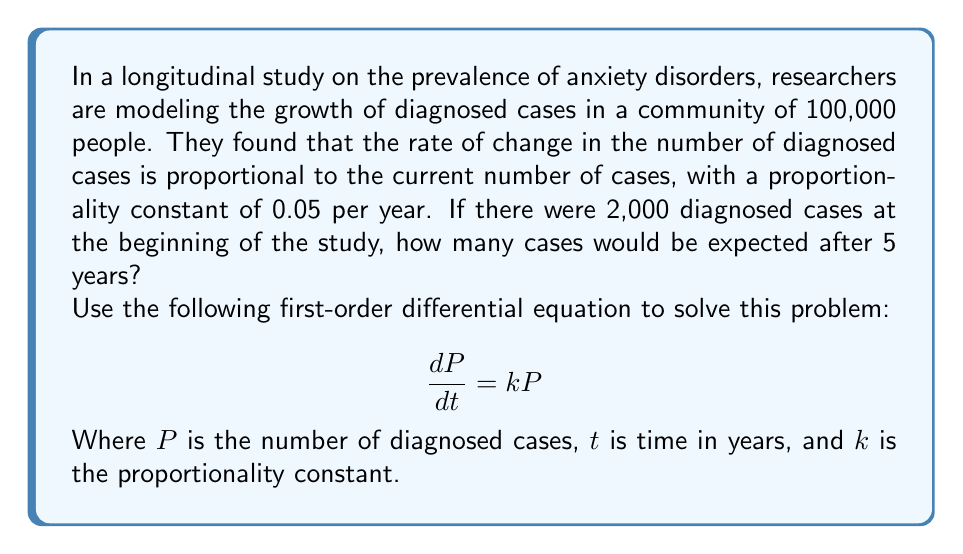Teach me how to tackle this problem. To solve this problem, we'll use the given first-order differential equation and the initial conditions:

1. Given differential equation: $\frac{dP}{dt} = kP$
2. Initial condition: $P(0) = 2000$
3. Proportionality constant: $k = 0.05$
4. Time period: $t = 5$ years

Step 1: Solve the differential equation
The solution to this equation is an exponential function:
$$P(t) = P_0e^{kt}$$
Where $P_0$ is the initial number of cases.

Step 2: Substitute the known values
$$P(t) = 2000e^{0.05t}$$

Step 3: Calculate the number of cases after 5 years
$$P(5) = 2000e^{0.05 \cdot 5}$$
$$P(5) = 2000e^{0.25}$$

Step 4: Evaluate the exponential function
$$P(5) = 2000 \cdot 1.2840$$
$$P(5) = 2568$$

Therefore, after 5 years, we would expect approximately 2,568 diagnosed cases of anxiety disorders in the community.

This model demonstrates exponential growth, which is common in early stages of disease spread or diagnosis rates in epidemiological studies. However, it's important to note that in real-world scenarios, growth often slows down over time due to various factors, leading to logistic growth rather than continued exponential growth.
Answer: After 5 years, there would be approximately 2,568 diagnosed cases of anxiety disorders in the community. 